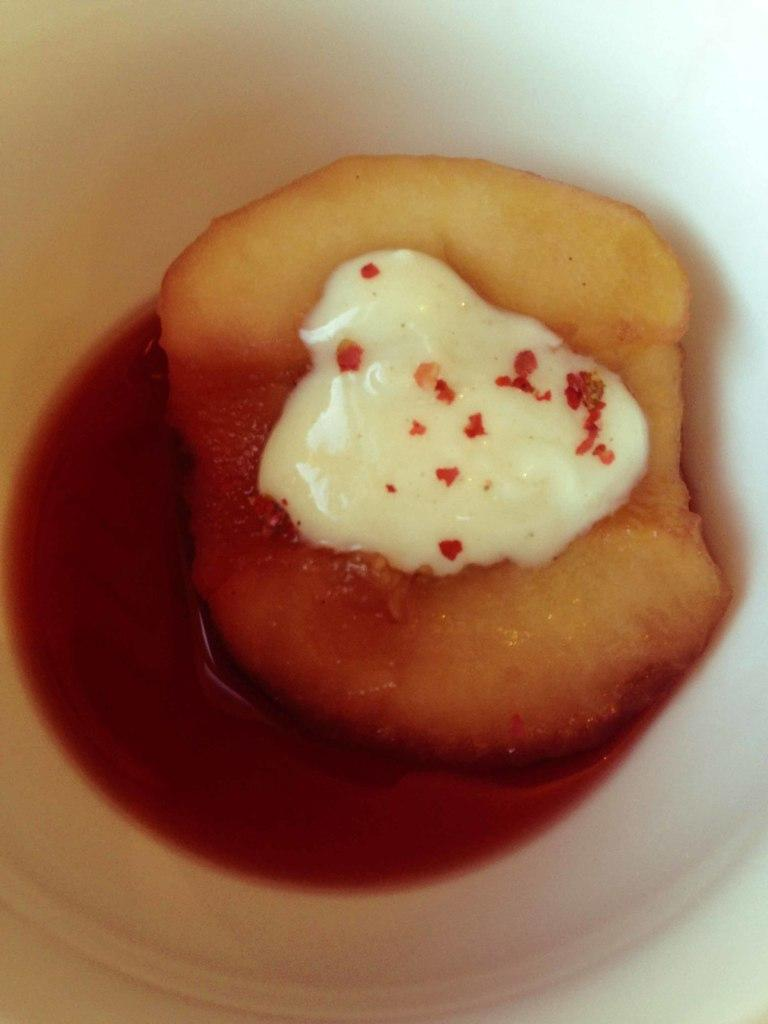What is the color of the object in the image? The object in the image is white. What is inside the object? The object contains food items. Where is the object located in the image? The object is in the center of the image. How many aunts are sitting on the chairs in the image? There are no chairs or aunts present in the image. 